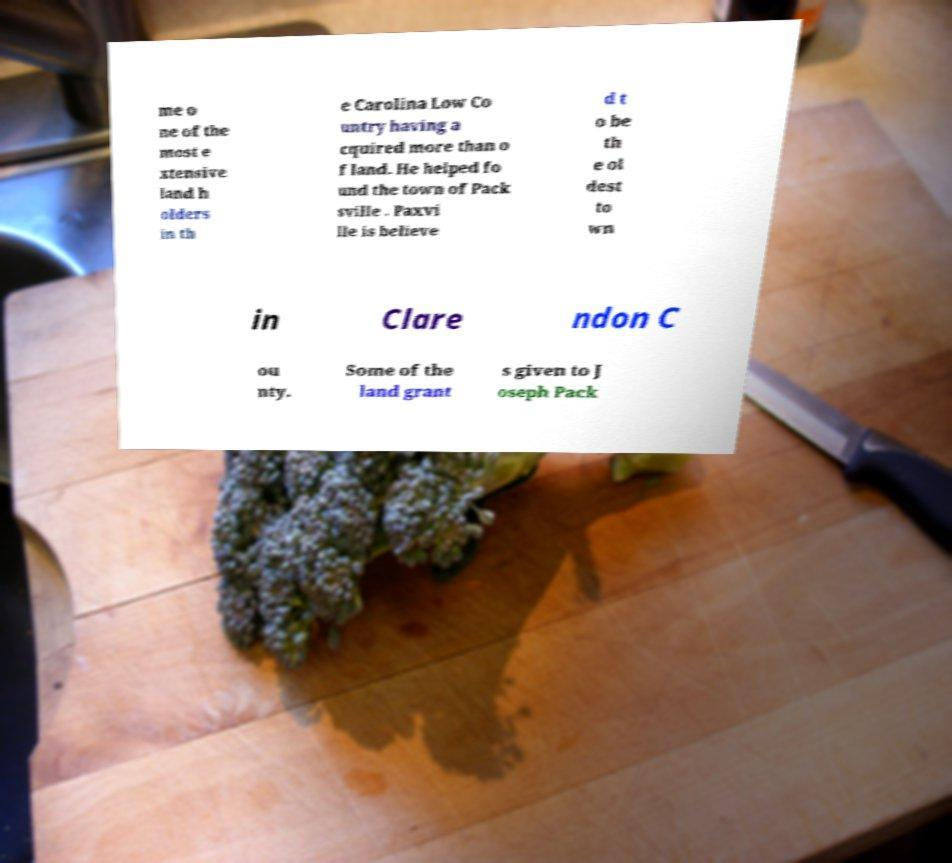Please read and relay the text visible in this image. What does it say? me o ne of the most e xtensive land h olders in th e Carolina Low Co untry having a cquired more than o f land. He helped fo und the town of Pack sville . Paxvi lle is believe d t o be th e ol dest to wn in Clare ndon C ou nty. Some of the land grant s given to J oseph Pack 